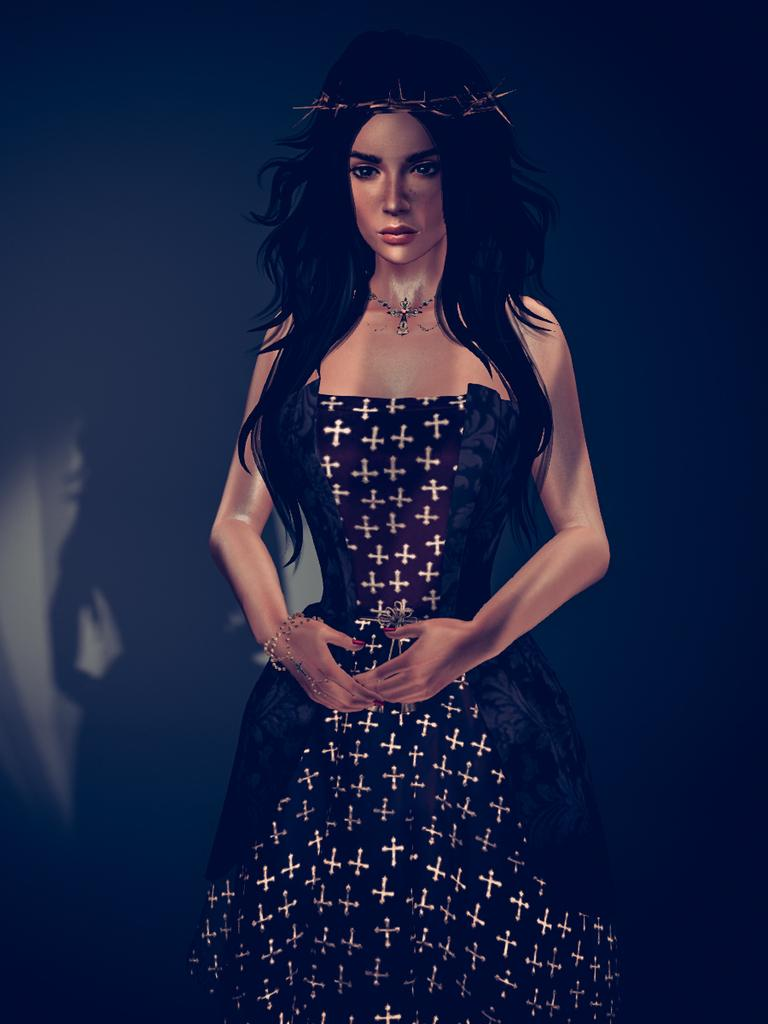What style is the image drawn in? The image is a cartoon. Can you describe the main subject of the image? There is a woman in the image. How many pizzas can be seen in the image? There are no pizzas present in the image. What is the woman teaching in the image? The image does not depict the woman teaching anything; it is a cartoon of a woman, and no context is provided for her actions or activities. 